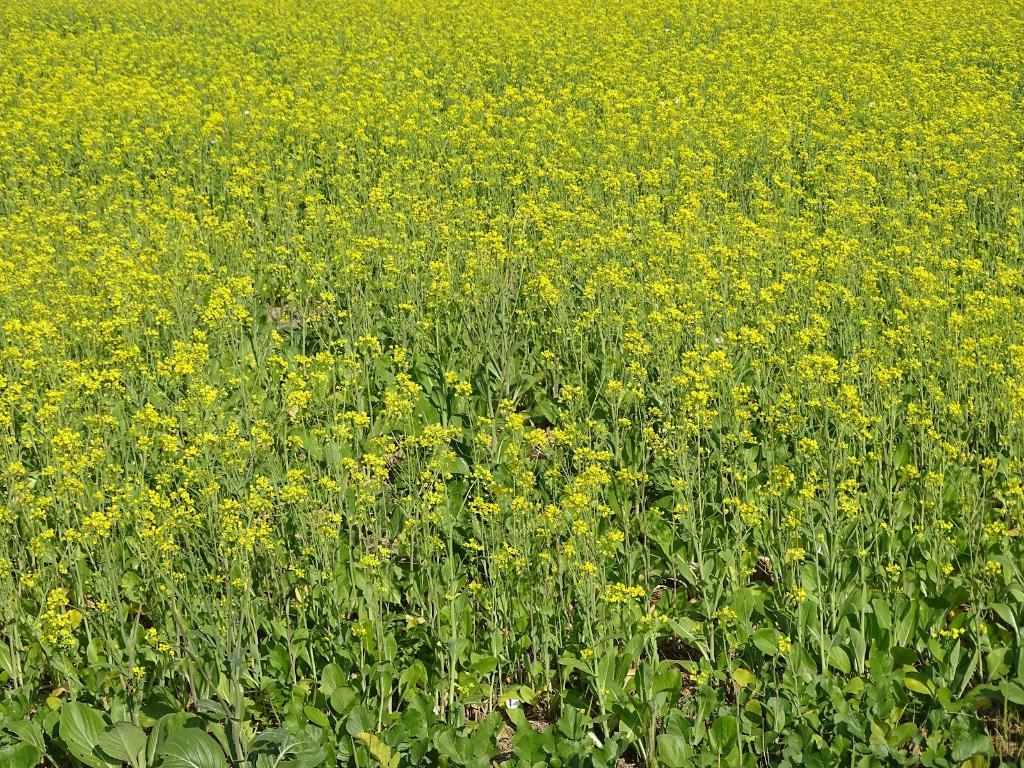What type of living organisms can be seen in the image? Plants can be seen in the image. What additional features can be observed on the plants? The plants have flowers. How does the plant provide comfort to the person in the image? There is no person present in the image, and plants do not provide comfort in the way humans do. 